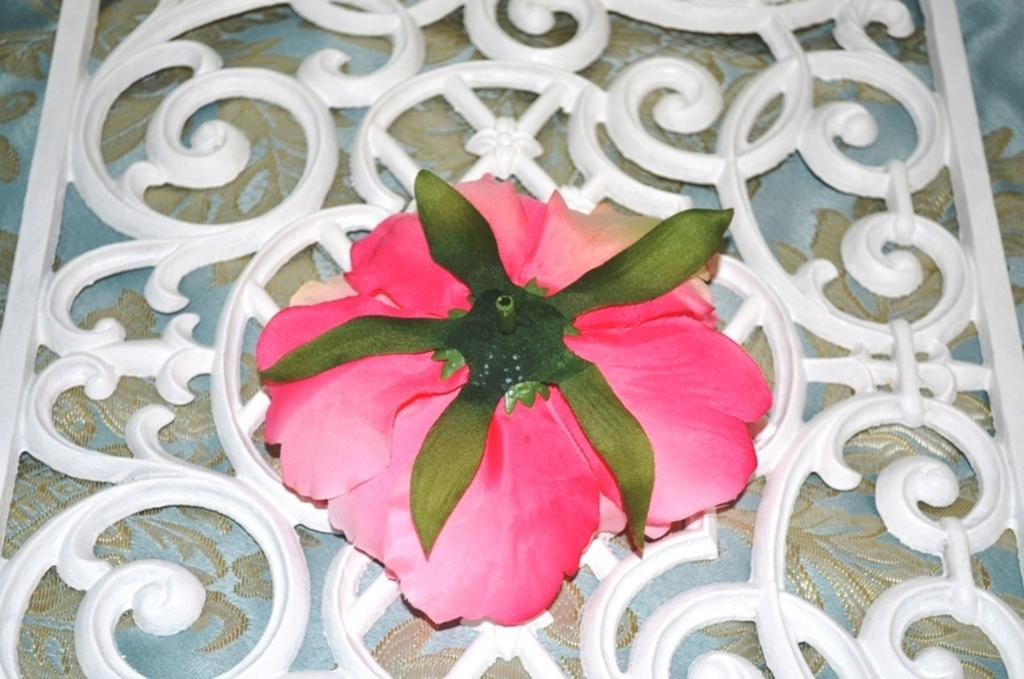What type of flower is in the image? There is a pink rose flower in the image. How is the rose flower arranged? The rose flower is arranged in reverse. What is the color of the fencing on which the flower is placed? The flower is on a white color fencing. Where is the fencing located? The fencing is on a curtain. How does the memory of the flower affect the adjustment of the hook in the image? There is no memory, hook, or adjustment present in the image; it only features a pink rose flower arranged in reverse on a white color fencing that is on a curtain. 